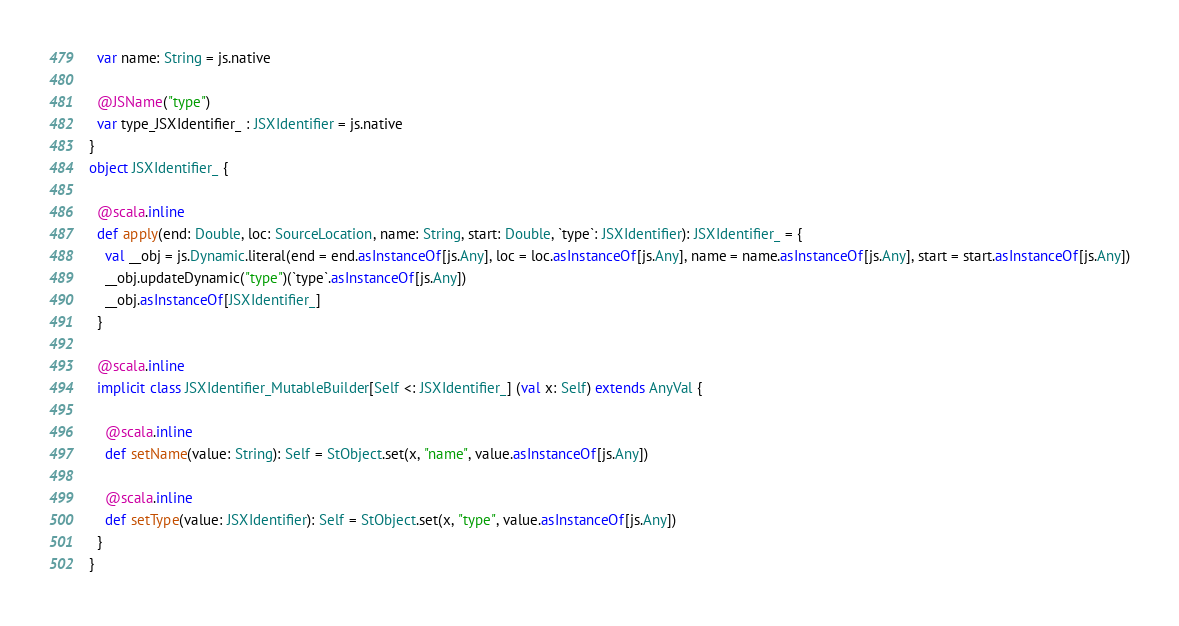<code> <loc_0><loc_0><loc_500><loc_500><_Scala_>  var name: String = js.native
  
  @JSName("type")
  var type_JSXIdentifier_ : JSXIdentifier = js.native
}
object JSXIdentifier_ {
  
  @scala.inline
  def apply(end: Double, loc: SourceLocation, name: String, start: Double, `type`: JSXIdentifier): JSXIdentifier_ = {
    val __obj = js.Dynamic.literal(end = end.asInstanceOf[js.Any], loc = loc.asInstanceOf[js.Any], name = name.asInstanceOf[js.Any], start = start.asInstanceOf[js.Any])
    __obj.updateDynamic("type")(`type`.asInstanceOf[js.Any])
    __obj.asInstanceOf[JSXIdentifier_]
  }
  
  @scala.inline
  implicit class JSXIdentifier_MutableBuilder[Self <: JSXIdentifier_] (val x: Self) extends AnyVal {
    
    @scala.inline
    def setName(value: String): Self = StObject.set(x, "name", value.asInstanceOf[js.Any])
    
    @scala.inline
    def setType(value: JSXIdentifier): Self = StObject.set(x, "type", value.asInstanceOf[js.Any])
  }
}
</code> 